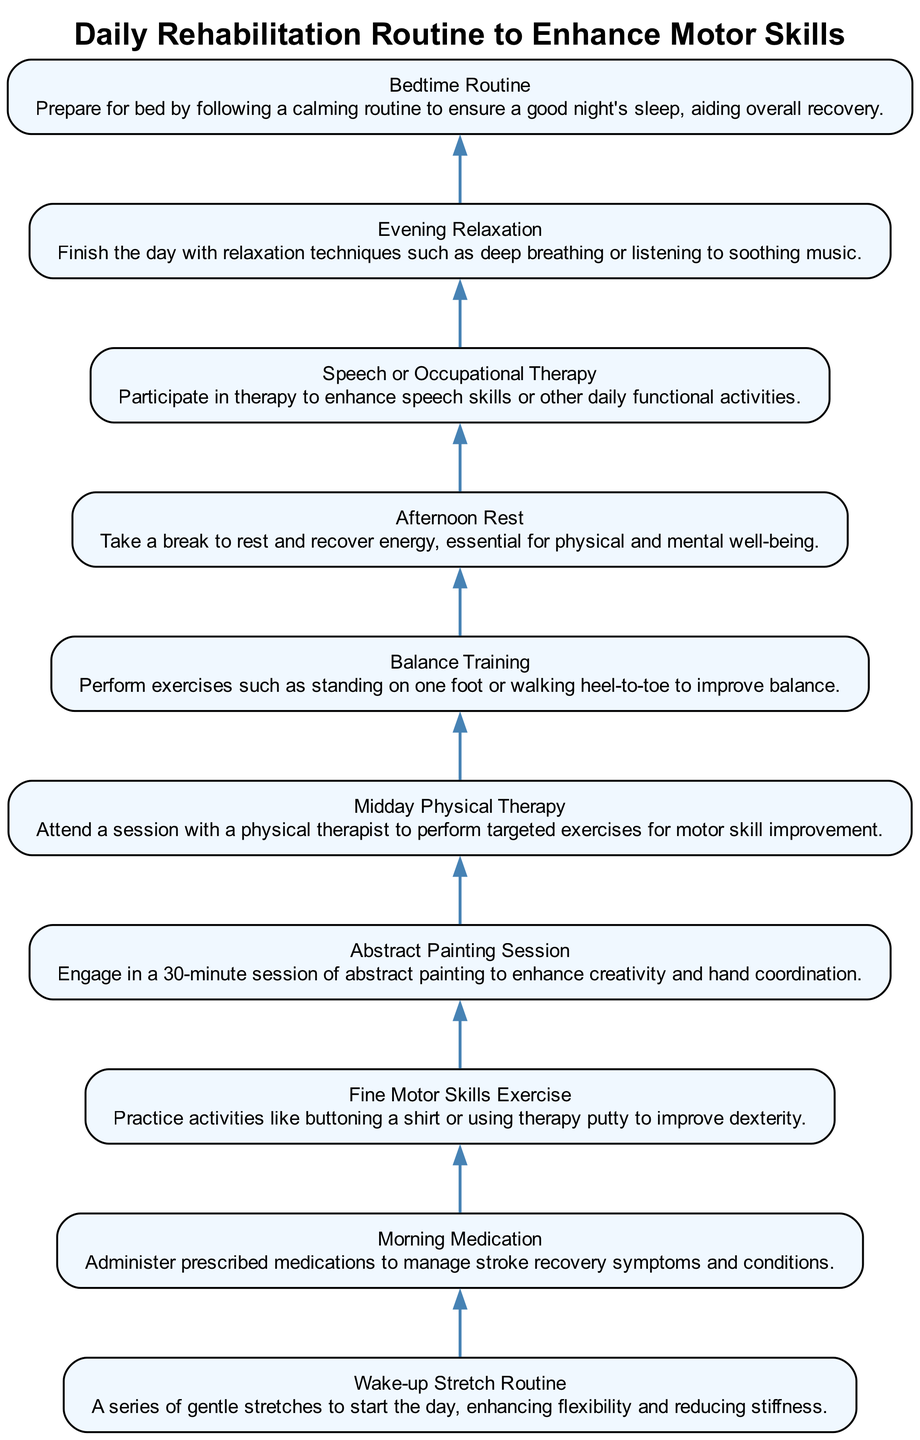What's the first step in the daily rehabilitation routine? According to the diagram, the first step at the bottom is the "Wake-up Stretch Routine". The steps flow upwards starting from this node.
Answer: Wake-up Stretch Routine How many total steps are there in the daily rehabilitation routine? The diagram illustrates a total of ten steps as it lists each routine from the "Wake-up Stretch Routine" up to the "Bedtime Routine". Counting each of these nodes provides the total.
Answer: 10 What activity follows after the Fine Motor Skills Exercise? From the visual flow, after the "Fine Motor Skills Exercise" the next step is the "Abstract Painting Session". The relationship is a direct upward flow from one node to the next.
Answer: Abstract Painting Session Which steps involve physical activity? Looking at the diagram, the steps that involve physical activity are the "Midday Physical Therapy" and "Balance Training". Both are specifically designed to enhance physical motor skills.
Answer: Midday Physical Therapy, Balance Training What is the last step in the rehabilitation routine? The last step at the top of the flowchart is the "Bedtime Routine". The diagram ends with this node, indicating the final part of the daily routine.
Answer: Bedtime Routine Which activity is designed to improve creativity? The diagram clearly indicates that the "Abstract Painting Session" is the activity aimed at enhancing creativity, situated just after fine motor skills exercises.
Answer: Abstract Painting Session What is the immediate activity before the Afternoon Rest? According to the flowchart, immediately before the "Afternoon Rest" is the "Balance Training", which is one step lower in the flow.
Answer: Balance Training How does the Evening Relaxation relate to the rest of the routine? The "Evening Relaxation" step concludes the day’s activities, indicating a transition from active rehabilitation efforts to winding down, as shown by its positioning at the top of the chart.
Answer: It concludes the day’s routine 